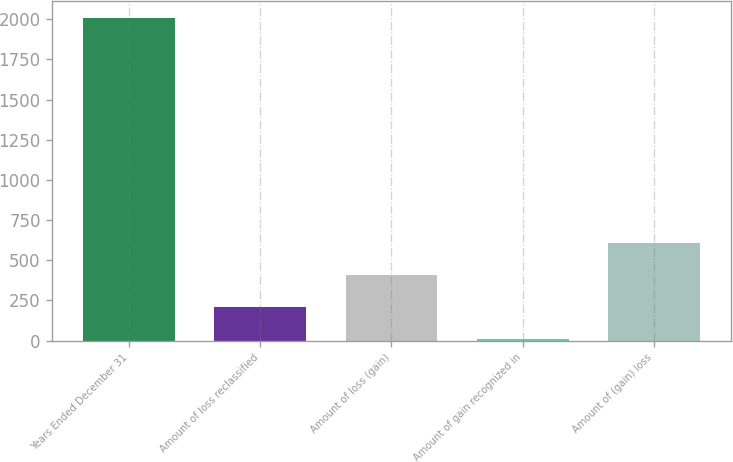<chart> <loc_0><loc_0><loc_500><loc_500><bar_chart><fcel>Years Ended December 31<fcel>Amount of loss reclassified<fcel>Amount of loss (gain)<fcel>Amount of gain recognized in<fcel>Amount of (gain) loss<nl><fcel>2011<fcel>210.1<fcel>410.2<fcel>10<fcel>610.3<nl></chart> 